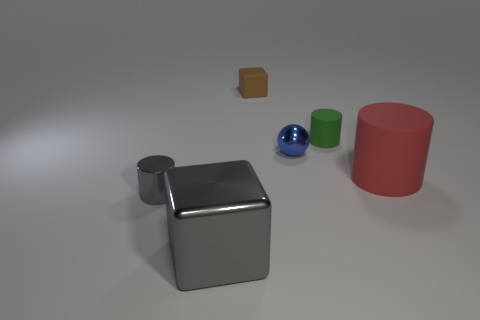What material is the large gray object? The large gray object appears to be a cube made of metal, likely stainless steel or aluminum, given its reflective surface and characteristic silver-gray color. 